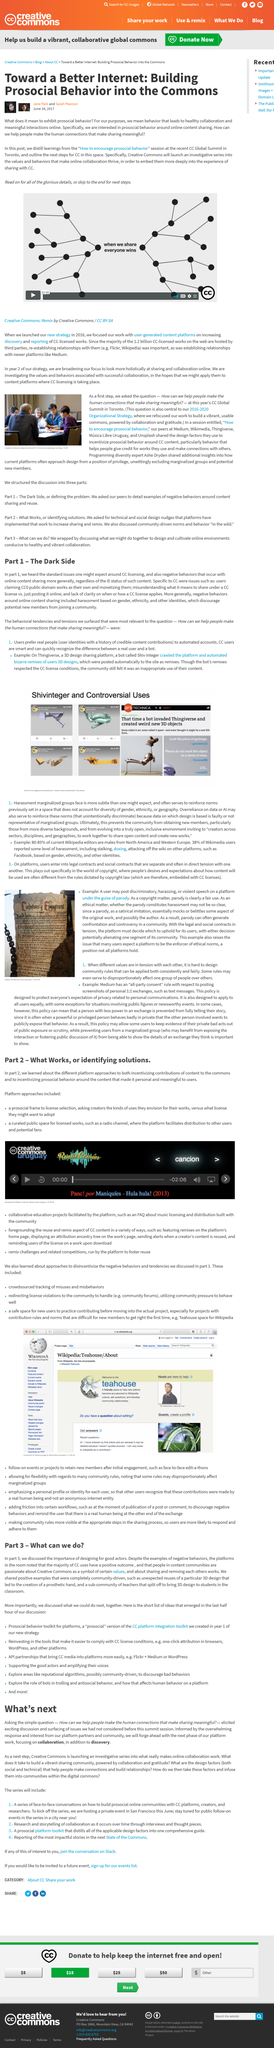Indicate a few pertinent items in this graphic. At the 2017 Global Summit, CC asked the question, "How can we help people make the human connections that make sharing meaningful? We propose to integrate prosocial behavior into the commons to construct a better internet. The image in the article is from the Creative Commons Global Summit in 2017. The articles discussed in the article relate to CC licensing. The recent session of the CC Global Summit took place in Toronto. 